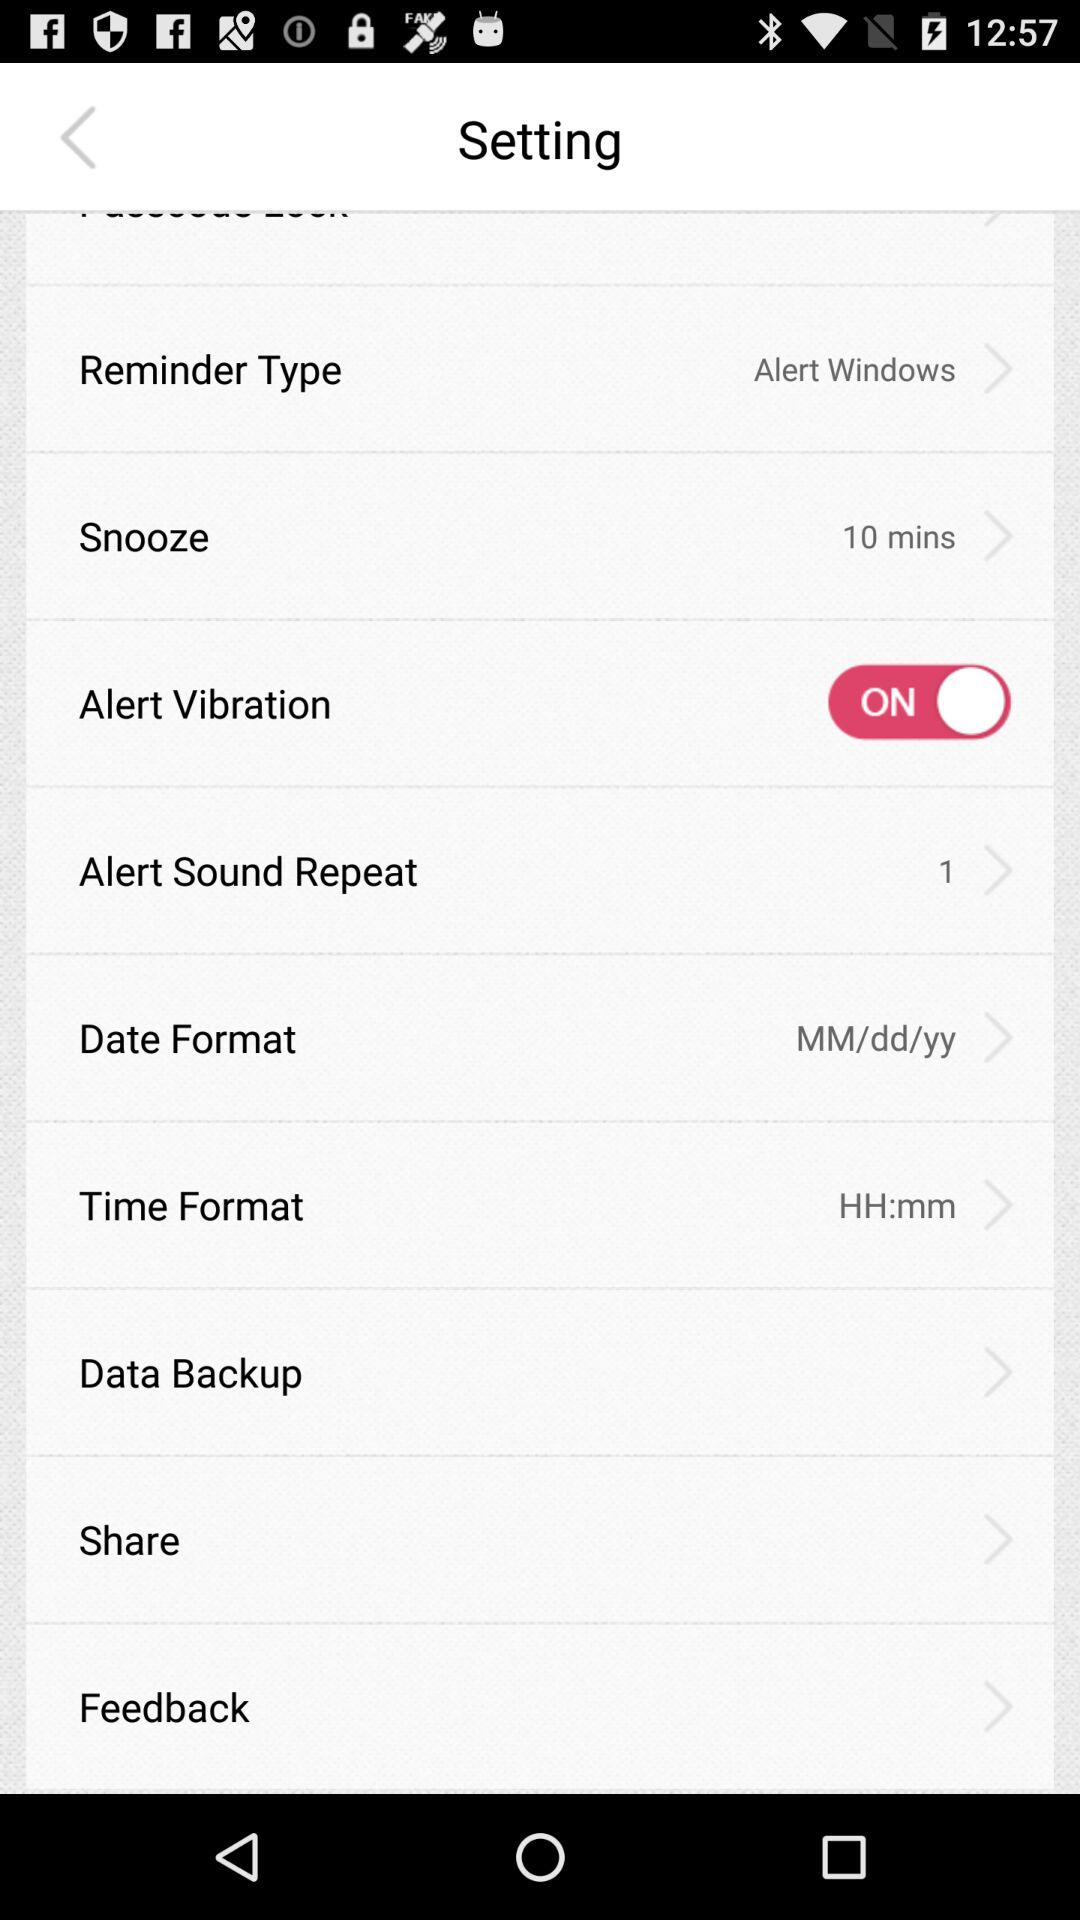For what option "Alert Windows" are selected? The option is "Reminder Type". 